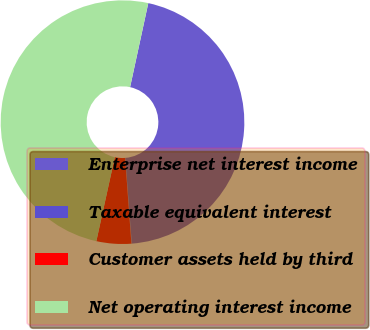Convert chart. <chart><loc_0><loc_0><loc_500><loc_500><pie_chart><fcel>Enterprise net interest income<fcel>Taxable equivalent interest<fcel>Customer assets held by third<fcel>Net operating interest income<nl><fcel>45.39%<fcel>0.05%<fcel>4.61%<fcel>49.95%<nl></chart> 